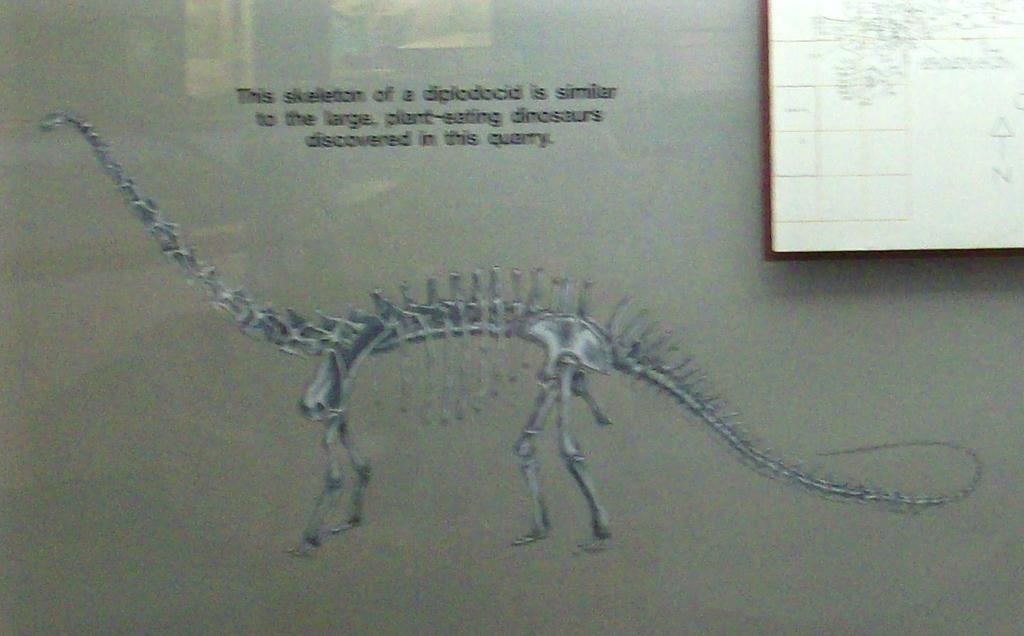<image>
Write a terse but informative summary of the picture. A dinosaur skeleton is shown along with text that says this dinosaur is similar to the large plant-eating dinosaurs. 